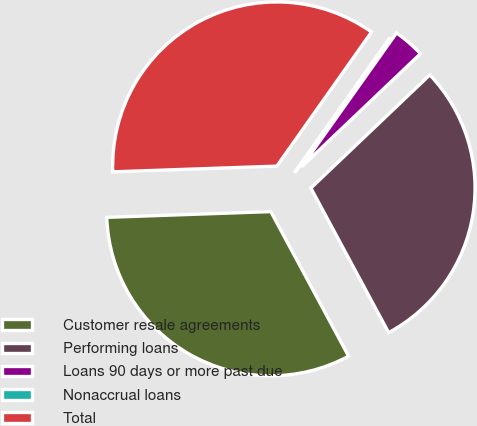Convert chart. <chart><loc_0><loc_0><loc_500><loc_500><pie_chart><fcel>Customer resale agreements<fcel>Performing loans<fcel>Loans 90 days or more past due<fcel>Nonaccrual loans<fcel>Total<nl><fcel>32.3%<fcel>29.25%<fcel>3.08%<fcel>0.03%<fcel>35.34%<nl></chart> 